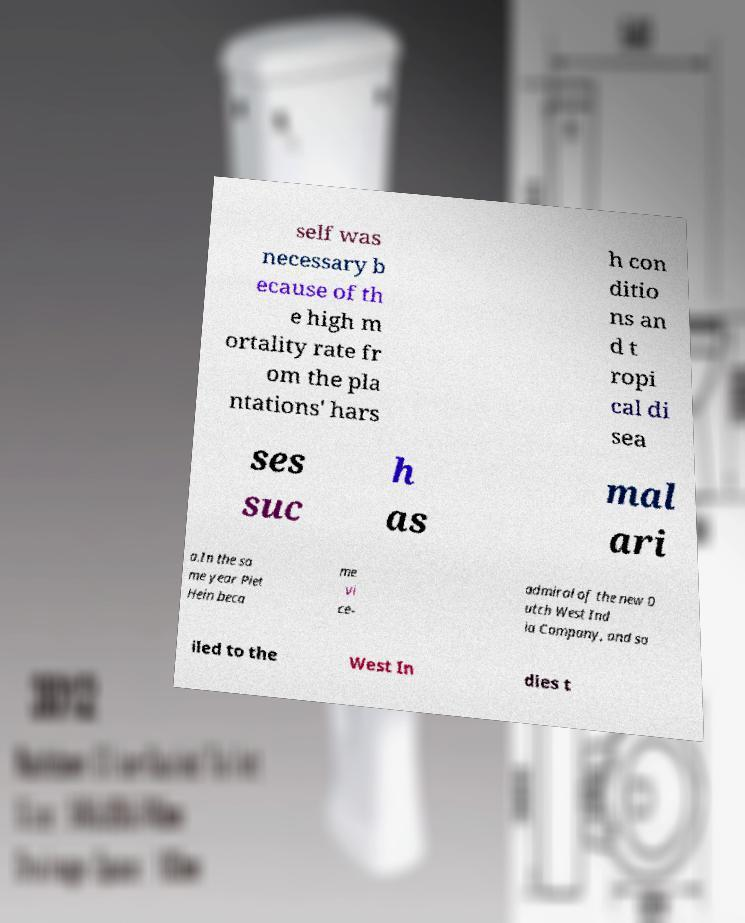Could you assist in decoding the text presented in this image and type it out clearly? self was necessary b ecause of th e high m ortality rate fr om the pla ntations' hars h con ditio ns an d t ropi cal di sea ses suc h as mal ari a.In the sa me year Piet Hein beca me vi ce- admiral of the new D utch West Ind ia Company, and sa iled to the West In dies t 